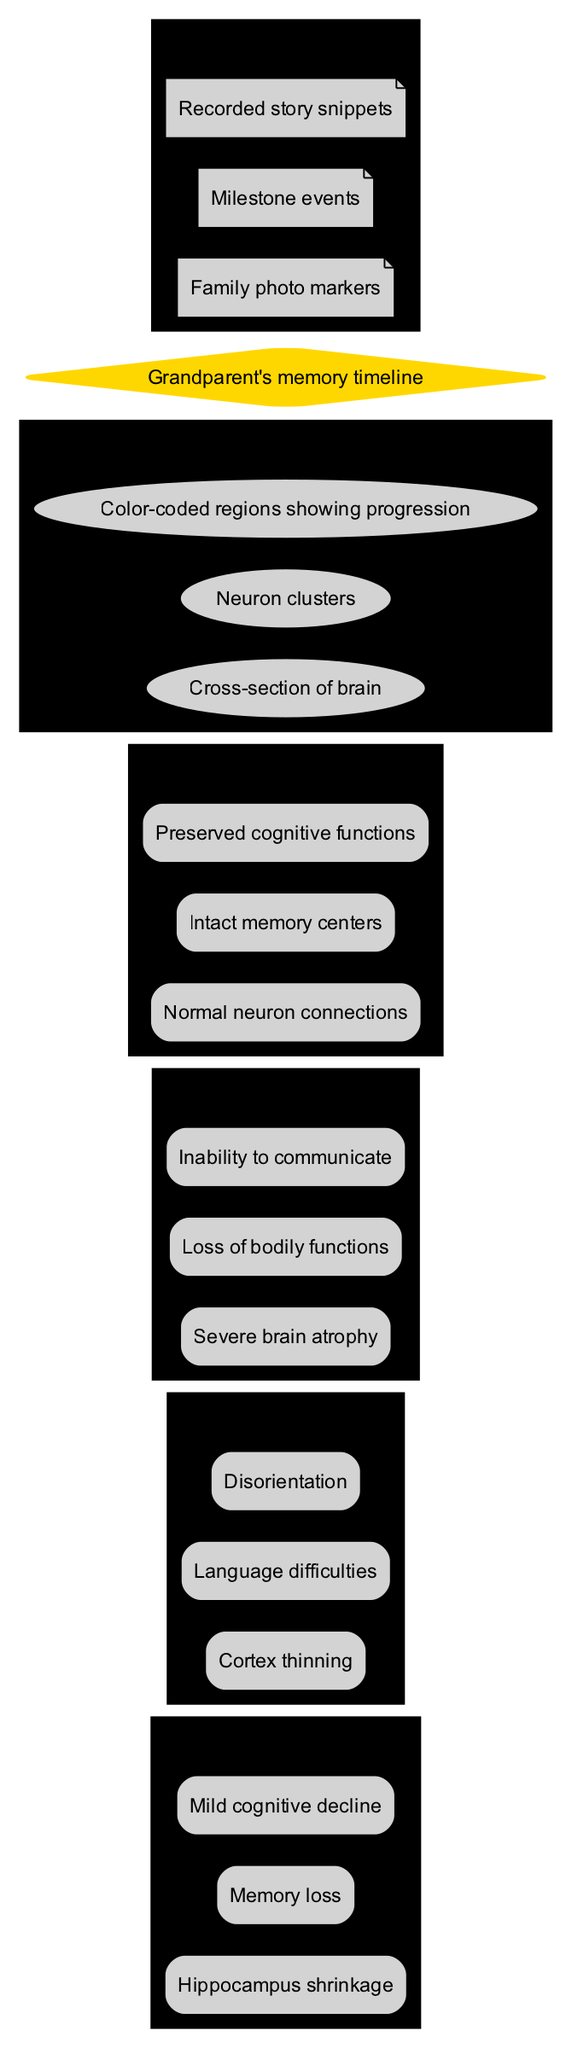What is the first brain change in the Early Stage? In the diagram, the brain changes are listed under each stage. The first brain change listed in the Early Stage is "Hippocampus shrinkage."
Answer: Hippocampus shrinkage How many brain changes are listed for the Late Stage? The Late Stage has three brain changes listed in the diagram: "Severe brain atrophy," "Loss of bodily functions," and "Inability to communicate."
Answer: 3 What color represents the Healthy Brain cluster? In the diagram, the Healthy Brain cluster is labeled with the color "/9/1/.6," which visually differentiates it from the other stages.
Answer: /9/1/.6 Which milestone element is included in the Storytelling Elements? The Storytelling Elements section includes items such as "Family photo markers," which is one of the elements listed in the diagram under that category.
Answer: Family photo markers What relationship can be deduced between normal neuron connections and cognitive decline? The diagram shows that "Normal neuron connections" are part of the Healthy Brain cluster, while cognitive decline indicates a deterioration in brain health. This contrast highlights that the presence of normal connections is crucial for maintaining cognitive functions, thus implicating a relationship of dependence.
Answer: Dependence What stage involves language difficulties? The Middle Stage lists "Language difficulties" as one of the brain changes, indicating the cognitive challenges experienced at this point in Alzheimer's progression.
Answer: Middle Stage How many stages of Alzheimer’s disease progression are depicted in the diagram? The diagram visually depicts three distinct stages of Alzheimer's disease progression: Early Stage, Middle Stage, and Late Stage.
Answer: 3 What are the visual elements included in the diagram? The visual elements section lists items such as "Cross-section of brain," "Neuron clusters," and "Color-coded regions showing progression," which enhance understanding of the health states depicted.
Answer: Cross-section of brain, Neuron clusters, Color-coded regions showing progression 